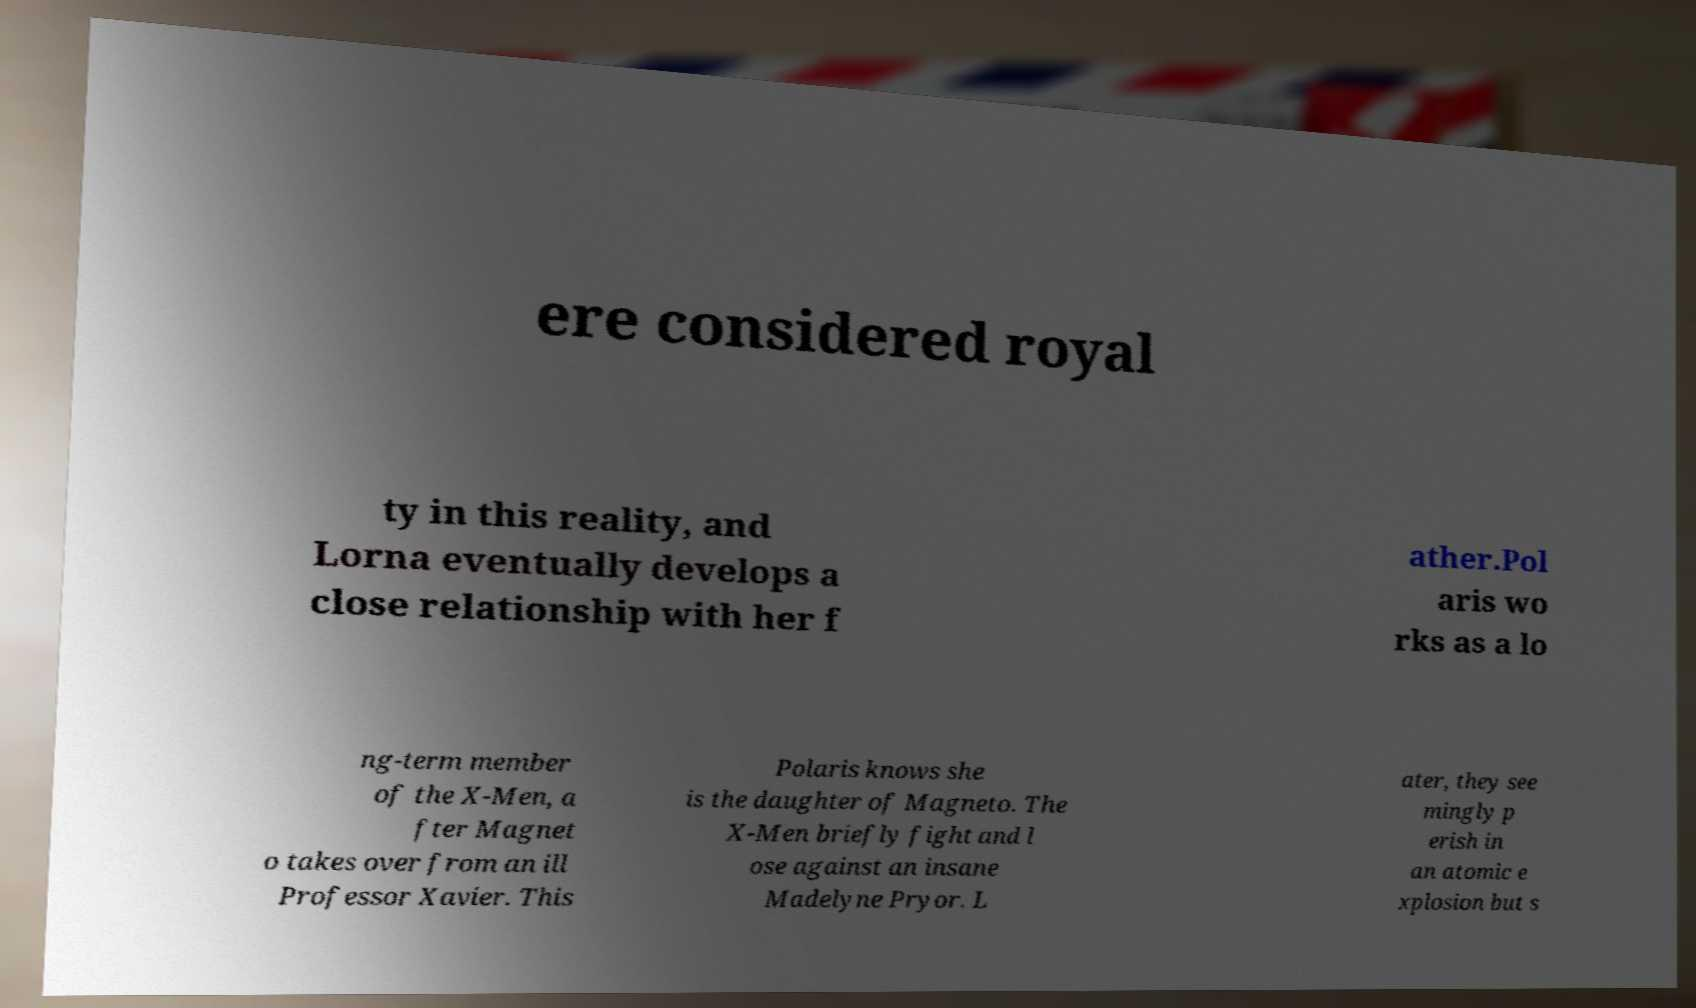Could you assist in decoding the text presented in this image and type it out clearly? ere considered royal ty in this reality, and Lorna eventually develops a close relationship with her f ather.Pol aris wo rks as a lo ng-term member of the X-Men, a fter Magnet o takes over from an ill Professor Xavier. This Polaris knows she is the daughter of Magneto. The X-Men briefly fight and l ose against an insane Madelyne Pryor. L ater, they see mingly p erish in an atomic e xplosion but s 